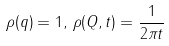<formula> <loc_0><loc_0><loc_500><loc_500>\rho ( q ) = 1 , \, \rho ( Q , t ) = { \frac { 1 } { 2 \pi t } }</formula> 